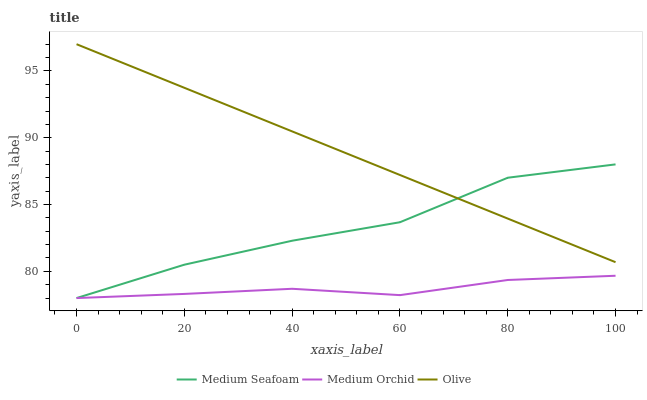Does Medium Orchid have the minimum area under the curve?
Answer yes or no. Yes. Does Olive have the maximum area under the curve?
Answer yes or no. Yes. Does Medium Seafoam have the minimum area under the curve?
Answer yes or no. No. Does Medium Seafoam have the maximum area under the curve?
Answer yes or no. No. Is Olive the smoothest?
Answer yes or no. Yes. Is Medium Seafoam the roughest?
Answer yes or no. Yes. Is Medium Orchid the smoothest?
Answer yes or no. No. Is Medium Orchid the roughest?
Answer yes or no. No. Does Medium Orchid have the lowest value?
Answer yes or no. Yes. Does Olive have the highest value?
Answer yes or no. Yes. Does Medium Seafoam have the highest value?
Answer yes or no. No. Is Medium Orchid less than Olive?
Answer yes or no. Yes. Is Olive greater than Medium Orchid?
Answer yes or no. Yes. Does Olive intersect Medium Seafoam?
Answer yes or no. Yes. Is Olive less than Medium Seafoam?
Answer yes or no. No. Is Olive greater than Medium Seafoam?
Answer yes or no. No. Does Medium Orchid intersect Olive?
Answer yes or no. No. 